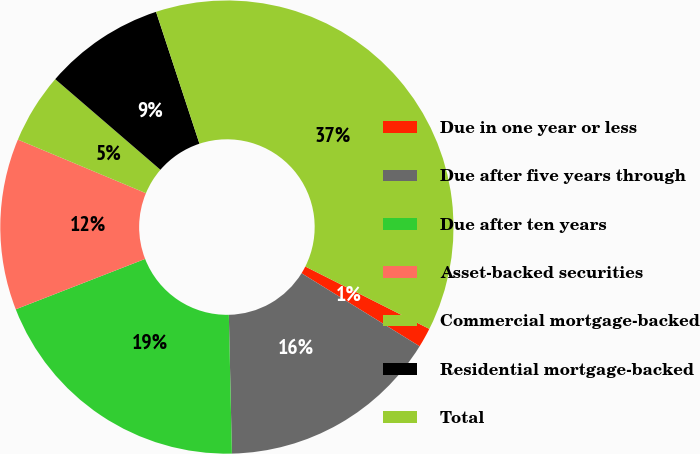Convert chart. <chart><loc_0><loc_0><loc_500><loc_500><pie_chart><fcel>Due in one year or less<fcel>Due after five years through<fcel>Due after ten years<fcel>Asset-backed securities<fcel>Commercial mortgage-backed<fcel>Residential mortgage-backed<fcel>Total<nl><fcel>1.4%<fcel>15.83%<fcel>19.44%<fcel>12.22%<fcel>5.01%<fcel>8.62%<fcel>37.48%<nl></chart> 